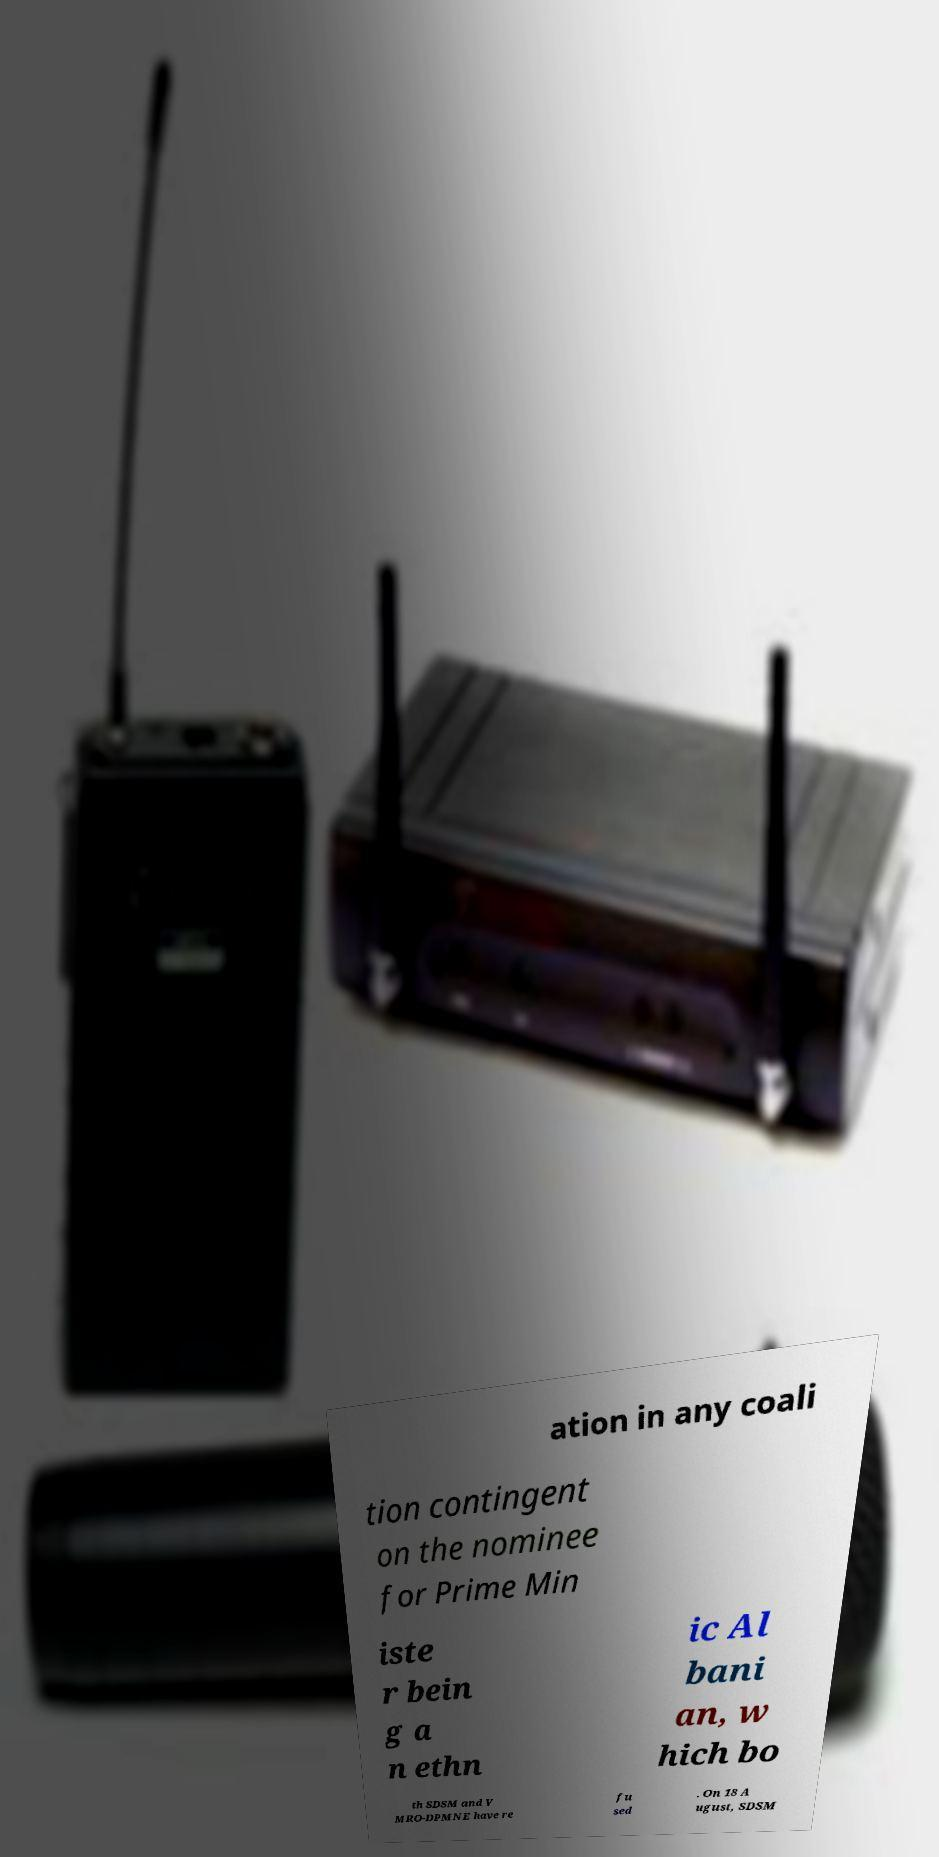Please read and relay the text visible in this image. What does it say? ation in any coali tion contingent on the nominee for Prime Min iste r bein g a n ethn ic Al bani an, w hich bo th SDSM and V MRO-DPMNE have re fu sed . On 18 A ugust, SDSM 